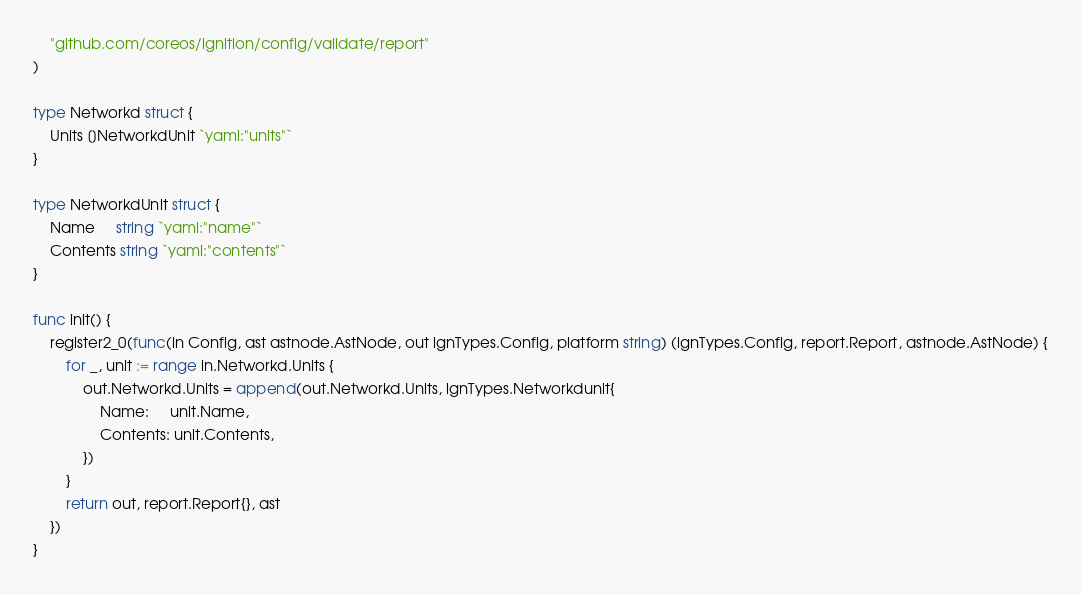Convert code to text. <code><loc_0><loc_0><loc_500><loc_500><_Go_>	"github.com/coreos/ignition/config/validate/report"
)

type Networkd struct {
	Units []NetworkdUnit `yaml:"units"`
}

type NetworkdUnit struct {
	Name     string `yaml:"name"`
	Contents string `yaml:"contents"`
}

func init() {
	register2_0(func(in Config, ast astnode.AstNode, out ignTypes.Config, platform string) (ignTypes.Config, report.Report, astnode.AstNode) {
		for _, unit := range in.Networkd.Units {
			out.Networkd.Units = append(out.Networkd.Units, ignTypes.Networkdunit{
				Name:     unit.Name,
				Contents: unit.Contents,
			})
		}
		return out, report.Report{}, ast
	})
}
</code> 